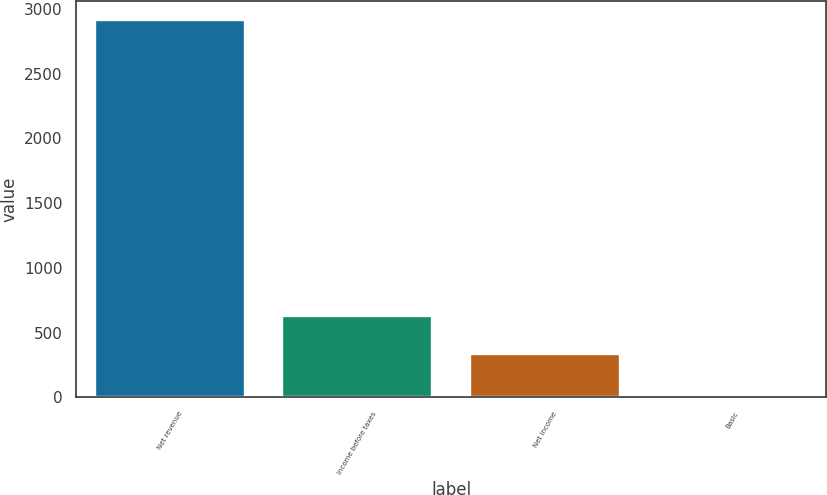Convert chart. <chart><loc_0><loc_0><loc_500><loc_500><bar_chart><fcel>Net revenue<fcel>Income before taxes<fcel>Net income<fcel>Basic<nl><fcel>2918<fcel>626.6<fcel>335<fcel>1.97<nl></chart> 